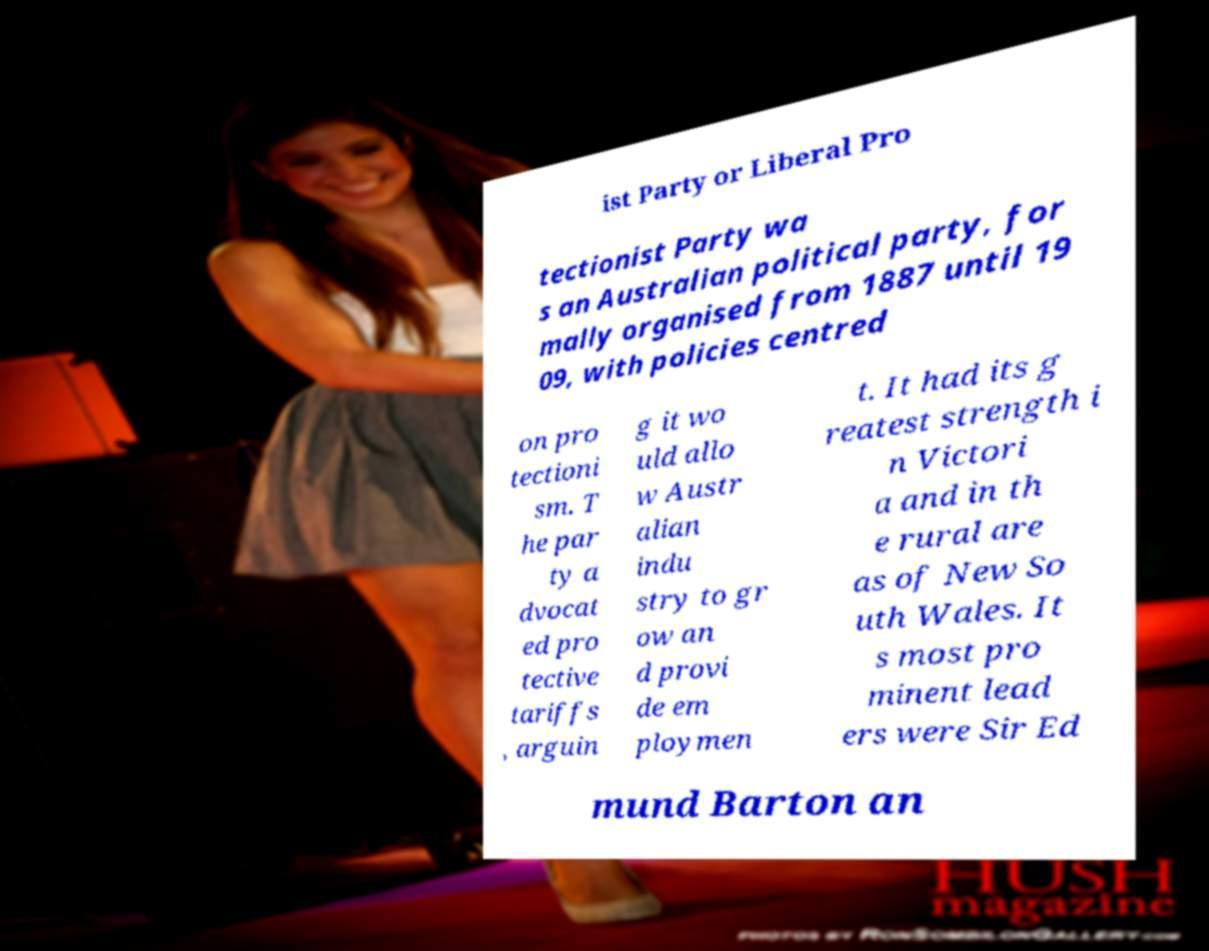For documentation purposes, I need the text within this image transcribed. Could you provide that? ist Party or Liberal Pro tectionist Party wa s an Australian political party, for mally organised from 1887 until 19 09, with policies centred on pro tectioni sm. T he par ty a dvocat ed pro tective tariffs , arguin g it wo uld allo w Austr alian indu stry to gr ow an d provi de em ploymen t. It had its g reatest strength i n Victori a and in th e rural are as of New So uth Wales. It s most pro minent lead ers were Sir Ed mund Barton an 